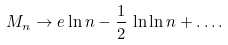Convert formula to latex. <formula><loc_0><loc_0><loc_500><loc_500>M _ { n } \to e \ln n - \frac { 1 } { 2 } \, \ln \ln n + \dots .</formula> 